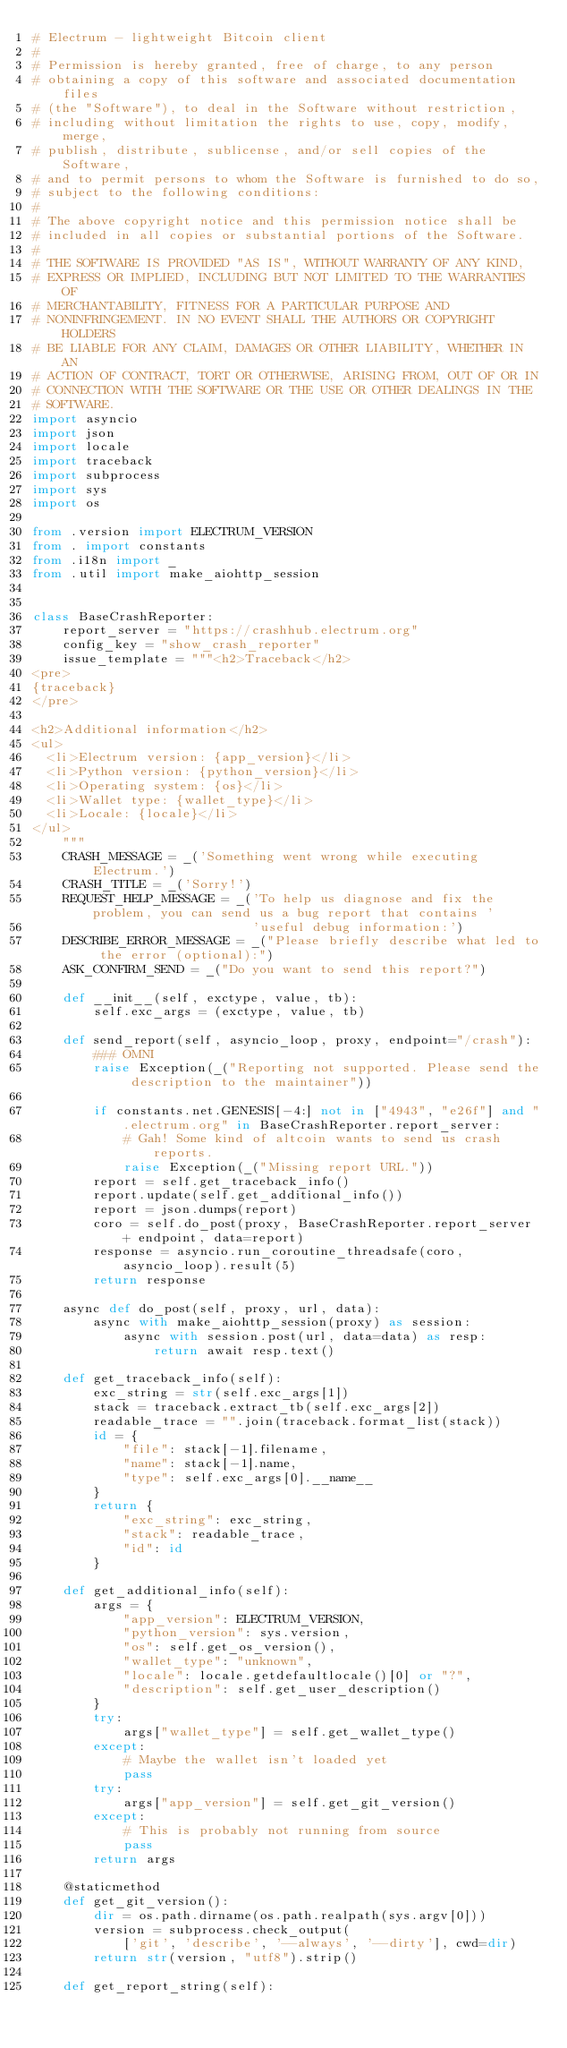<code> <loc_0><loc_0><loc_500><loc_500><_Python_># Electrum - lightweight Bitcoin client
#
# Permission is hereby granted, free of charge, to any person
# obtaining a copy of this software and associated documentation files
# (the "Software"), to deal in the Software without restriction,
# including without limitation the rights to use, copy, modify, merge,
# publish, distribute, sublicense, and/or sell copies of the Software,
# and to permit persons to whom the Software is furnished to do so,
# subject to the following conditions:
#
# The above copyright notice and this permission notice shall be
# included in all copies or substantial portions of the Software.
#
# THE SOFTWARE IS PROVIDED "AS IS", WITHOUT WARRANTY OF ANY KIND,
# EXPRESS OR IMPLIED, INCLUDING BUT NOT LIMITED TO THE WARRANTIES OF
# MERCHANTABILITY, FITNESS FOR A PARTICULAR PURPOSE AND
# NONINFRINGEMENT. IN NO EVENT SHALL THE AUTHORS OR COPYRIGHT HOLDERS
# BE LIABLE FOR ANY CLAIM, DAMAGES OR OTHER LIABILITY, WHETHER IN AN
# ACTION OF CONTRACT, TORT OR OTHERWISE, ARISING FROM, OUT OF OR IN
# CONNECTION WITH THE SOFTWARE OR THE USE OR OTHER DEALINGS IN THE
# SOFTWARE.
import asyncio
import json
import locale
import traceback
import subprocess
import sys
import os

from .version import ELECTRUM_VERSION
from . import constants
from .i18n import _
from .util import make_aiohttp_session


class BaseCrashReporter:
    report_server = "https://crashhub.electrum.org"
    config_key = "show_crash_reporter"
    issue_template = """<h2>Traceback</h2>
<pre>
{traceback}
</pre>

<h2>Additional information</h2>
<ul>
  <li>Electrum version: {app_version}</li>
  <li>Python version: {python_version}</li>
  <li>Operating system: {os}</li>
  <li>Wallet type: {wallet_type}</li>
  <li>Locale: {locale}</li>
</ul>
    """
    CRASH_MESSAGE = _('Something went wrong while executing Electrum.')
    CRASH_TITLE = _('Sorry!')
    REQUEST_HELP_MESSAGE = _('To help us diagnose and fix the problem, you can send us a bug report that contains '
                             'useful debug information:')
    DESCRIBE_ERROR_MESSAGE = _("Please briefly describe what led to the error (optional):")
    ASK_CONFIRM_SEND = _("Do you want to send this report?")

    def __init__(self, exctype, value, tb):
        self.exc_args = (exctype, value, tb)

    def send_report(self, asyncio_loop, proxy, endpoint="/crash"):
        ### OMNI
        raise Exception(_("Reporting not supported. Please send the description to the maintainer"))

        if constants.net.GENESIS[-4:] not in ["4943", "e26f"] and ".electrum.org" in BaseCrashReporter.report_server:
            # Gah! Some kind of altcoin wants to send us crash reports.
            raise Exception(_("Missing report URL."))
        report = self.get_traceback_info()
        report.update(self.get_additional_info())
        report = json.dumps(report)
        coro = self.do_post(proxy, BaseCrashReporter.report_server + endpoint, data=report)
        response = asyncio.run_coroutine_threadsafe(coro, asyncio_loop).result(5)
        return response

    async def do_post(self, proxy, url, data):
        async with make_aiohttp_session(proxy) as session:
            async with session.post(url, data=data) as resp:
                return await resp.text()

    def get_traceback_info(self):
        exc_string = str(self.exc_args[1])
        stack = traceback.extract_tb(self.exc_args[2])
        readable_trace = "".join(traceback.format_list(stack))
        id = {
            "file": stack[-1].filename,
            "name": stack[-1].name,
            "type": self.exc_args[0].__name__
        }
        return {
            "exc_string": exc_string,
            "stack": readable_trace,
            "id": id
        }

    def get_additional_info(self):
        args = {
            "app_version": ELECTRUM_VERSION,
            "python_version": sys.version,
            "os": self.get_os_version(),
            "wallet_type": "unknown",
            "locale": locale.getdefaultlocale()[0] or "?",
            "description": self.get_user_description()
        }
        try:
            args["wallet_type"] = self.get_wallet_type()
        except:
            # Maybe the wallet isn't loaded yet
            pass
        try:
            args["app_version"] = self.get_git_version()
        except:
            # This is probably not running from source
            pass
        return args

    @staticmethod
    def get_git_version():
        dir = os.path.dirname(os.path.realpath(sys.argv[0]))
        version = subprocess.check_output(
            ['git', 'describe', '--always', '--dirty'], cwd=dir)
        return str(version, "utf8").strip()

    def get_report_string(self):</code> 